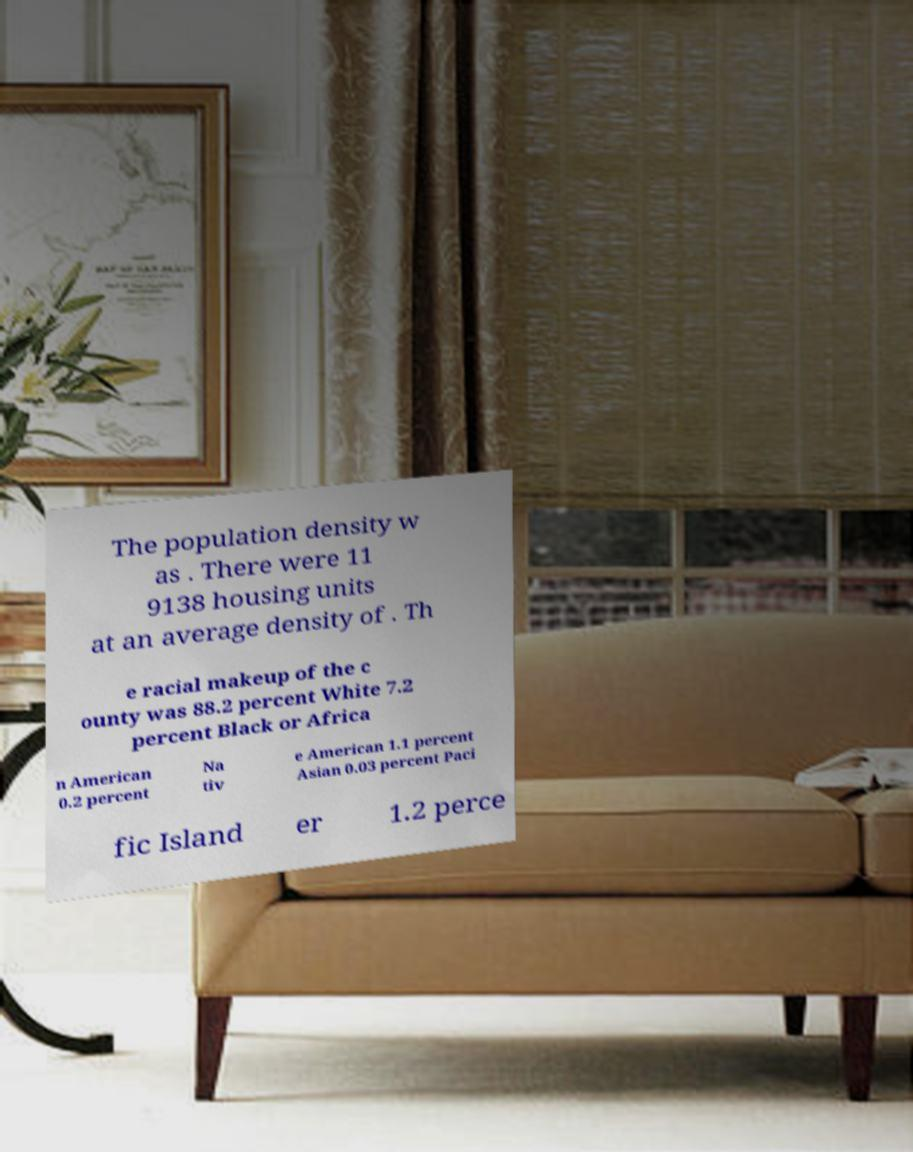What messages or text are displayed in this image? I need them in a readable, typed format. The population density w as . There were 11 9138 housing units at an average density of . Th e racial makeup of the c ounty was 88.2 percent White 7.2 percent Black or Africa n American 0.2 percent Na tiv e American 1.1 percent Asian 0.03 percent Paci fic Island er 1.2 perce 